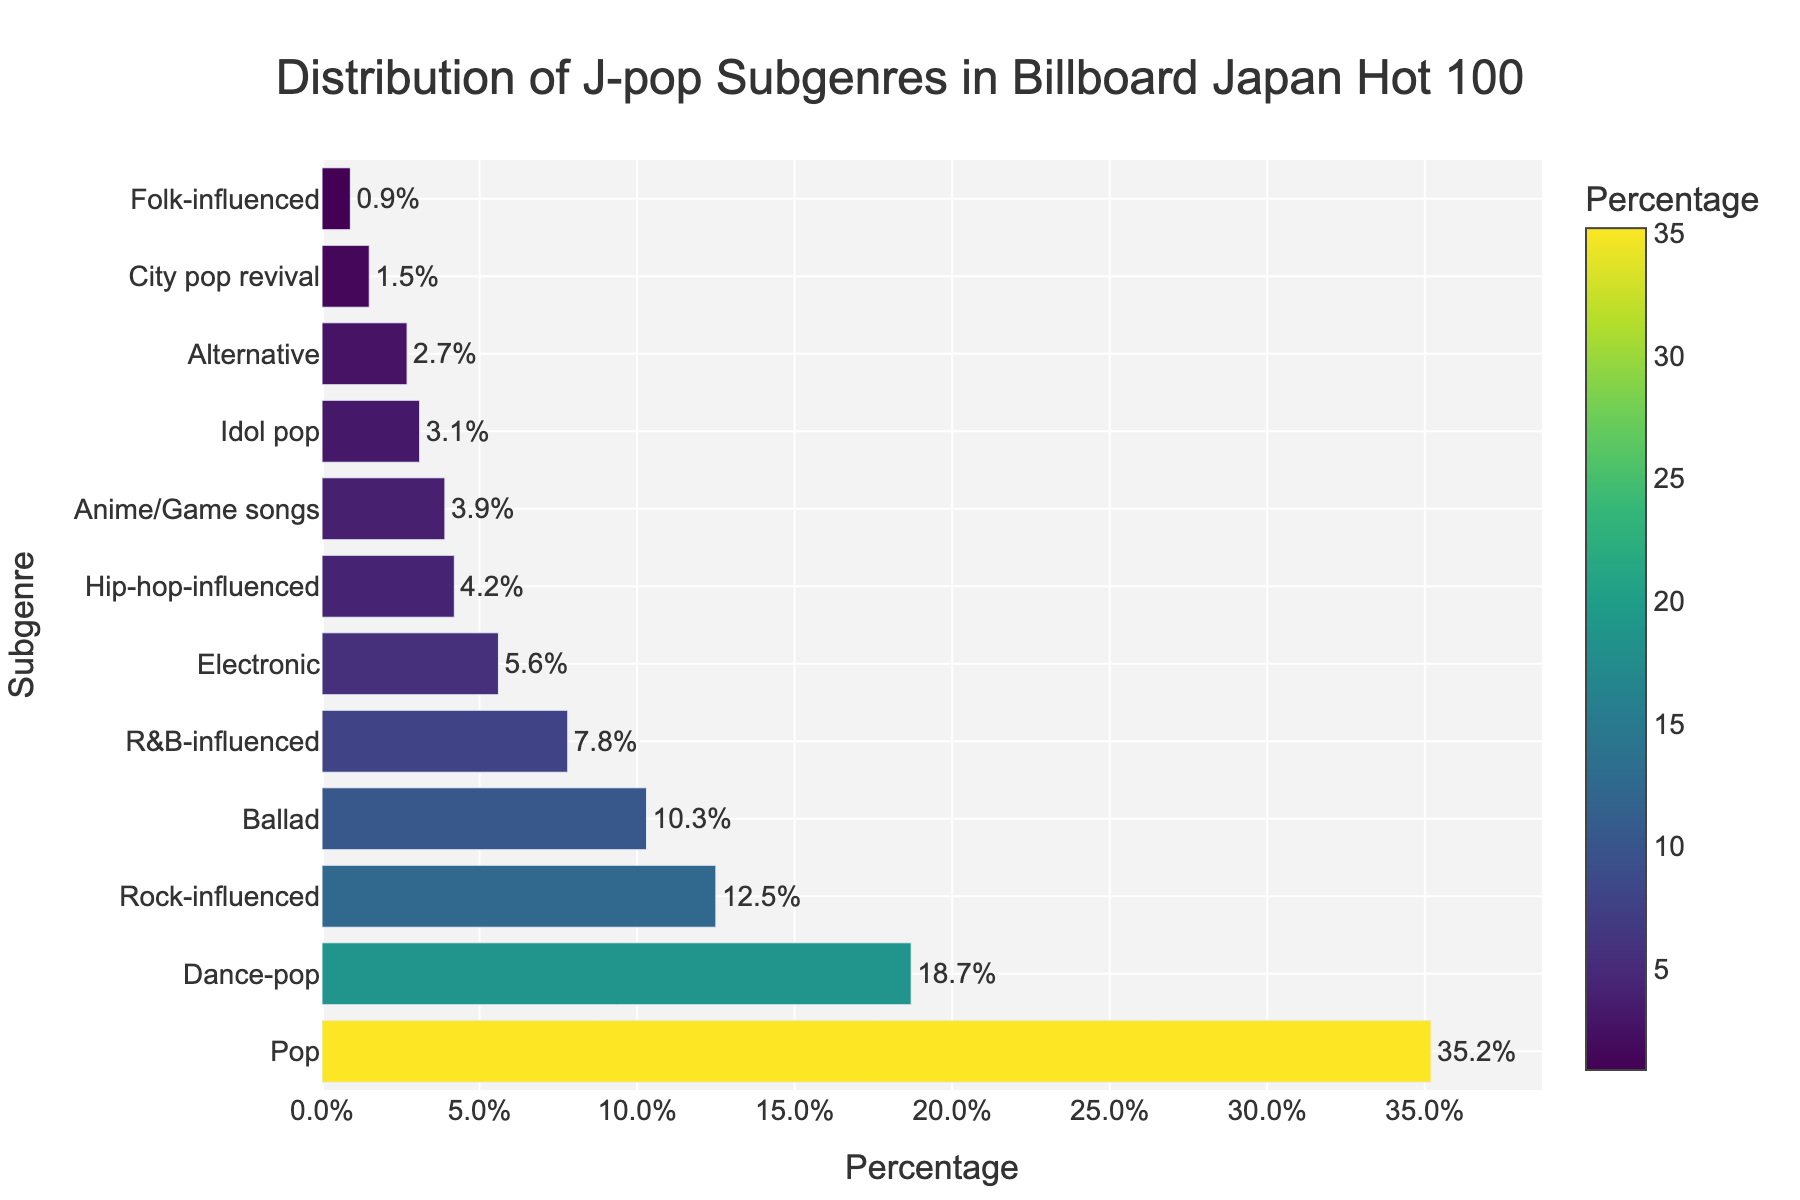Which J-pop subgenre holds the highest percentage? The bar chart shows the subgenres in descending order of percentage. The first subgenre listed has the highest percentage.
Answer: Pop What is the percentage difference between Pop and Dance-pop subgenres? Pop has 35.2%, and Dance-pop has 18.7%. Calculating the percentage difference: 35.2 - 18.7.
Answer: 16.5% How does the percentage of Rock-influenced compare to Ballad? Rock-influenced has 12.5%, and Ballad has 10.3%. It is higher.
Answer: Rock-influenced is higher Which subgenre has the lowest percentage? The last subgenre listed in the bar chart has the lowest percentage. It is Folk-influenced.
Answer: Folk-influenced What is the combined percentage of Anime/Game songs and Idol pop? Anime/Game songs have 3.9%, and Idol pop has 3.1%. Adding these together: 3.9 + 3.1 = 7.0.
Answer: 7.0% What subgenre is closest in percentage to Hip-hop-influenced? Hip-hop-influenced has 4.2%. The percentage closest to it is Anime/Game songs with 3.9%.
Answer: Anime/Game songs How many subgenres have a percentage greater than 10%? Subgenres with percentages greater than 10% are Pop (35.2%), Dance-pop (18.7%), and Rock-influenced (12.5%). There are three.
Answer: 3 Which subgenre has a slightly darker color compared to R&B-influenced due to its percentage? The color gets darker with increasing percentage. R&B-influenced has 7.8%, and Electronic has 5.6%. Ballad, which has 10.3%, is slightly darker.
Answer: Ballad What is approximately the average percentage of the top four subgenres? The top four subgenres are Pop (35.2%), Dance-pop (18.7%), Rock-influenced (12.5%), and Ballad (10.3%). The average is (35.2 + 18.7 + 12.5 + 10.3) / 4 = 76.7 / 4 ≈ 19.2.
Answer: 19.2% Compare the color contrast of the bars representing Dance-pop and City pop revival. Which one appears darker? Dance-pop has 18.7% and City pop revival has 1.5%. Higher percentages have darker colors. So, Dance-pop appears darker.
Answer: Dance-pop 